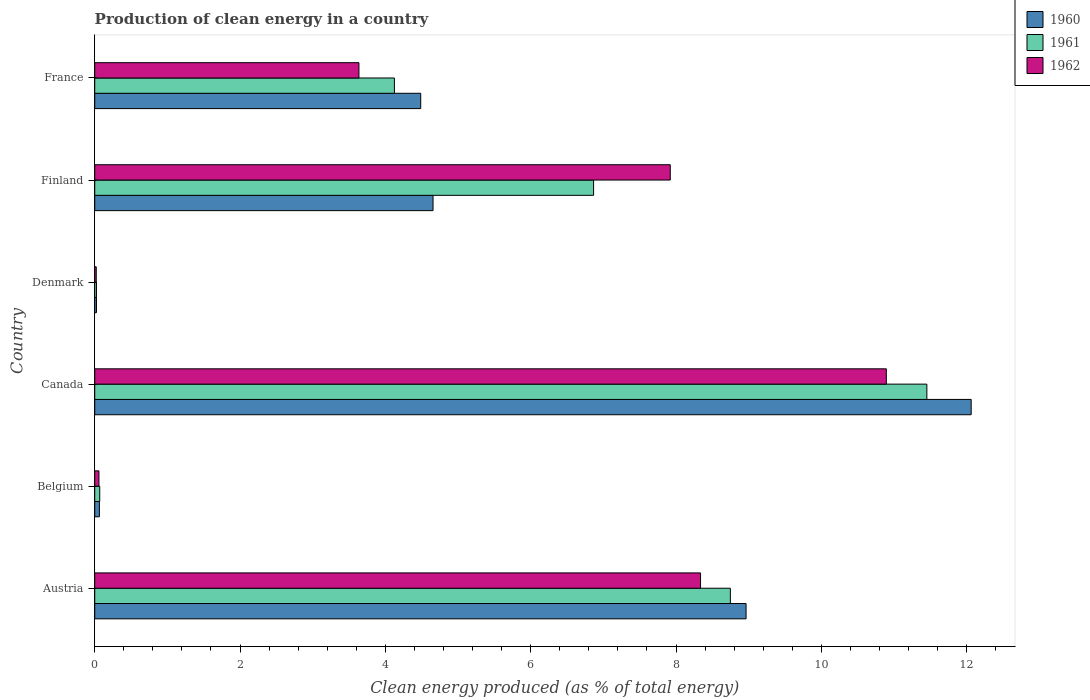How many different coloured bars are there?
Your answer should be very brief. 3. How many bars are there on the 4th tick from the bottom?
Make the answer very short. 3. What is the label of the 6th group of bars from the top?
Provide a succinct answer. Austria. What is the percentage of clean energy produced in 1960 in Belgium?
Ensure brevity in your answer.  0.06. Across all countries, what is the maximum percentage of clean energy produced in 1961?
Give a very brief answer. 11.45. Across all countries, what is the minimum percentage of clean energy produced in 1962?
Your response must be concise. 0.02. In which country was the percentage of clean energy produced in 1960 maximum?
Provide a short and direct response. Canada. What is the total percentage of clean energy produced in 1961 in the graph?
Provide a succinct answer. 31.28. What is the difference between the percentage of clean energy produced in 1961 in Denmark and that in Finland?
Offer a very short reply. -6.84. What is the difference between the percentage of clean energy produced in 1962 in Denmark and the percentage of clean energy produced in 1961 in Belgium?
Ensure brevity in your answer.  -0.05. What is the average percentage of clean energy produced in 1961 per country?
Keep it short and to the point. 5.21. What is the difference between the percentage of clean energy produced in 1961 and percentage of clean energy produced in 1962 in Finland?
Your answer should be compact. -1.06. In how many countries, is the percentage of clean energy produced in 1961 greater than 2.4 %?
Make the answer very short. 4. What is the ratio of the percentage of clean energy produced in 1960 in Canada to that in France?
Provide a short and direct response. 2.69. What is the difference between the highest and the second highest percentage of clean energy produced in 1961?
Keep it short and to the point. 2.7. What is the difference between the highest and the lowest percentage of clean energy produced in 1960?
Offer a very short reply. 12.04. Is the sum of the percentage of clean energy produced in 1962 in Belgium and Canada greater than the maximum percentage of clean energy produced in 1961 across all countries?
Your response must be concise. No. What does the 2nd bar from the top in Denmark represents?
Ensure brevity in your answer.  1961. Is it the case that in every country, the sum of the percentage of clean energy produced in 1960 and percentage of clean energy produced in 1962 is greater than the percentage of clean energy produced in 1961?
Your answer should be compact. Yes. How many bars are there?
Your answer should be compact. 18. How many countries are there in the graph?
Ensure brevity in your answer.  6. What is the difference between two consecutive major ticks on the X-axis?
Your answer should be compact. 2. Are the values on the major ticks of X-axis written in scientific E-notation?
Ensure brevity in your answer.  No. Where does the legend appear in the graph?
Your response must be concise. Top right. What is the title of the graph?
Your answer should be compact. Production of clean energy in a country. Does "2001" appear as one of the legend labels in the graph?
Offer a very short reply. No. What is the label or title of the X-axis?
Offer a very short reply. Clean energy produced (as % of total energy). What is the Clean energy produced (as % of total energy) in 1960 in Austria?
Provide a short and direct response. 8.96. What is the Clean energy produced (as % of total energy) in 1961 in Austria?
Make the answer very short. 8.75. What is the Clean energy produced (as % of total energy) of 1962 in Austria?
Your response must be concise. 8.34. What is the Clean energy produced (as % of total energy) of 1960 in Belgium?
Give a very brief answer. 0.06. What is the Clean energy produced (as % of total energy) of 1961 in Belgium?
Provide a succinct answer. 0.07. What is the Clean energy produced (as % of total energy) in 1962 in Belgium?
Ensure brevity in your answer.  0.06. What is the Clean energy produced (as % of total energy) in 1960 in Canada?
Offer a very short reply. 12.06. What is the Clean energy produced (as % of total energy) of 1961 in Canada?
Ensure brevity in your answer.  11.45. What is the Clean energy produced (as % of total energy) of 1962 in Canada?
Your response must be concise. 10.89. What is the Clean energy produced (as % of total energy) in 1960 in Denmark?
Provide a short and direct response. 0.02. What is the Clean energy produced (as % of total energy) of 1961 in Denmark?
Provide a short and direct response. 0.02. What is the Clean energy produced (as % of total energy) in 1962 in Denmark?
Your answer should be very brief. 0.02. What is the Clean energy produced (as % of total energy) of 1960 in Finland?
Make the answer very short. 4.66. What is the Clean energy produced (as % of total energy) of 1961 in Finland?
Ensure brevity in your answer.  6.87. What is the Clean energy produced (as % of total energy) of 1962 in Finland?
Offer a very short reply. 7.92. What is the Clean energy produced (as % of total energy) of 1960 in France?
Your answer should be very brief. 4.49. What is the Clean energy produced (as % of total energy) of 1961 in France?
Provide a succinct answer. 4.12. What is the Clean energy produced (as % of total energy) of 1962 in France?
Your answer should be compact. 3.64. Across all countries, what is the maximum Clean energy produced (as % of total energy) in 1960?
Your response must be concise. 12.06. Across all countries, what is the maximum Clean energy produced (as % of total energy) in 1961?
Offer a terse response. 11.45. Across all countries, what is the maximum Clean energy produced (as % of total energy) of 1962?
Your response must be concise. 10.89. Across all countries, what is the minimum Clean energy produced (as % of total energy) of 1960?
Your answer should be very brief. 0.02. Across all countries, what is the minimum Clean energy produced (as % of total energy) in 1961?
Provide a short and direct response. 0.02. Across all countries, what is the minimum Clean energy produced (as % of total energy) of 1962?
Provide a succinct answer. 0.02. What is the total Clean energy produced (as % of total energy) in 1960 in the graph?
Give a very brief answer. 30.26. What is the total Clean energy produced (as % of total energy) of 1961 in the graph?
Ensure brevity in your answer.  31.28. What is the total Clean energy produced (as % of total energy) in 1962 in the graph?
Your answer should be very brief. 30.87. What is the difference between the Clean energy produced (as % of total energy) in 1960 in Austria and that in Belgium?
Your answer should be very brief. 8.9. What is the difference between the Clean energy produced (as % of total energy) in 1961 in Austria and that in Belgium?
Your answer should be compact. 8.68. What is the difference between the Clean energy produced (as % of total energy) of 1962 in Austria and that in Belgium?
Offer a very short reply. 8.28. What is the difference between the Clean energy produced (as % of total energy) in 1960 in Austria and that in Canada?
Offer a terse response. -3.1. What is the difference between the Clean energy produced (as % of total energy) of 1961 in Austria and that in Canada?
Provide a succinct answer. -2.7. What is the difference between the Clean energy produced (as % of total energy) of 1962 in Austria and that in Canada?
Your response must be concise. -2.56. What is the difference between the Clean energy produced (as % of total energy) in 1960 in Austria and that in Denmark?
Make the answer very short. 8.94. What is the difference between the Clean energy produced (as % of total energy) in 1961 in Austria and that in Denmark?
Give a very brief answer. 8.72. What is the difference between the Clean energy produced (as % of total energy) in 1962 in Austria and that in Denmark?
Your answer should be compact. 8.32. What is the difference between the Clean energy produced (as % of total energy) of 1960 in Austria and that in Finland?
Offer a very short reply. 4.31. What is the difference between the Clean energy produced (as % of total energy) of 1961 in Austria and that in Finland?
Make the answer very short. 1.88. What is the difference between the Clean energy produced (as % of total energy) of 1962 in Austria and that in Finland?
Your answer should be very brief. 0.42. What is the difference between the Clean energy produced (as % of total energy) of 1960 in Austria and that in France?
Provide a succinct answer. 4.48. What is the difference between the Clean energy produced (as % of total energy) of 1961 in Austria and that in France?
Provide a succinct answer. 4.62. What is the difference between the Clean energy produced (as % of total energy) in 1962 in Austria and that in France?
Offer a terse response. 4.7. What is the difference between the Clean energy produced (as % of total energy) in 1960 in Belgium and that in Canada?
Offer a very short reply. -12. What is the difference between the Clean energy produced (as % of total energy) in 1961 in Belgium and that in Canada?
Provide a short and direct response. -11.38. What is the difference between the Clean energy produced (as % of total energy) of 1962 in Belgium and that in Canada?
Provide a short and direct response. -10.84. What is the difference between the Clean energy produced (as % of total energy) of 1960 in Belgium and that in Denmark?
Your answer should be very brief. 0.04. What is the difference between the Clean energy produced (as % of total energy) in 1961 in Belgium and that in Denmark?
Provide a succinct answer. 0.04. What is the difference between the Clean energy produced (as % of total energy) of 1962 in Belgium and that in Denmark?
Keep it short and to the point. 0.04. What is the difference between the Clean energy produced (as % of total energy) in 1960 in Belgium and that in Finland?
Provide a succinct answer. -4.59. What is the difference between the Clean energy produced (as % of total energy) in 1961 in Belgium and that in Finland?
Your response must be concise. -6.8. What is the difference between the Clean energy produced (as % of total energy) in 1962 in Belgium and that in Finland?
Make the answer very short. -7.86. What is the difference between the Clean energy produced (as % of total energy) of 1960 in Belgium and that in France?
Offer a very short reply. -4.42. What is the difference between the Clean energy produced (as % of total energy) of 1961 in Belgium and that in France?
Ensure brevity in your answer.  -4.06. What is the difference between the Clean energy produced (as % of total energy) of 1962 in Belgium and that in France?
Your response must be concise. -3.58. What is the difference between the Clean energy produced (as % of total energy) in 1960 in Canada and that in Denmark?
Your answer should be very brief. 12.04. What is the difference between the Clean energy produced (as % of total energy) in 1961 in Canada and that in Denmark?
Offer a terse response. 11.43. What is the difference between the Clean energy produced (as % of total energy) in 1962 in Canada and that in Denmark?
Ensure brevity in your answer.  10.87. What is the difference between the Clean energy produced (as % of total energy) of 1960 in Canada and that in Finland?
Your response must be concise. 7.41. What is the difference between the Clean energy produced (as % of total energy) in 1961 in Canada and that in Finland?
Ensure brevity in your answer.  4.59. What is the difference between the Clean energy produced (as % of total energy) of 1962 in Canada and that in Finland?
Keep it short and to the point. 2.97. What is the difference between the Clean energy produced (as % of total energy) of 1960 in Canada and that in France?
Give a very brief answer. 7.58. What is the difference between the Clean energy produced (as % of total energy) of 1961 in Canada and that in France?
Offer a very short reply. 7.33. What is the difference between the Clean energy produced (as % of total energy) in 1962 in Canada and that in France?
Make the answer very short. 7.26. What is the difference between the Clean energy produced (as % of total energy) of 1960 in Denmark and that in Finland?
Make the answer very short. -4.63. What is the difference between the Clean energy produced (as % of total energy) of 1961 in Denmark and that in Finland?
Offer a very short reply. -6.84. What is the difference between the Clean energy produced (as % of total energy) in 1962 in Denmark and that in Finland?
Your response must be concise. -7.9. What is the difference between the Clean energy produced (as % of total energy) of 1960 in Denmark and that in France?
Your answer should be very brief. -4.46. What is the difference between the Clean energy produced (as % of total energy) in 1961 in Denmark and that in France?
Provide a short and direct response. -4.1. What is the difference between the Clean energy produced (as % of total energy) in 1962 in Denmark and that in France?
Your answer should be compact. -3.62. What is the difference between the Clean energy produced (as % of total energy) of 1960 in Finland and that in France?
Offer a terse response. 0.17. What is the difference between the Clean energy produced (as % of total energy) of 1961 in Finland and that in France?
Keep it short and to the point. 2.74. What is the difference between the Clean energy produced (as % of total energy) in 1962 in Finland and that in France?
Make the answer very short. 4.28. What is the difference between the Clean energy produced (as % of total energy) of 1960 in Austria and the Clean energy produced (as % of total energy) of 1961 in Belgium?
Keep it short and to the point. 8.9. What is the difference between the Clean energy produced (as % of total energy) of 1960 in Austria and the Clean energy produced (as % of total energy) of 1962 in Belgium?
Provide a succinct answer. 8.91. What is the difference between the Clean energy produced (as % of total energy) of 1961 in Austria and the Clean energy produced (as % of total energy) of 1962 in Belgium?
Provide a short and direct response. 8.69. What is the difference between the Clean energy produced (as % of total energy) in 1960 in Austria and the Clean energy produced (as % of total energy) in 1961 in Canada?
Make the answer very short. -2.49. What is the difference between the Clean energy produced (as % of total energy) of 1960 in Austria and the Clean energy produced (as % of total energy) of 1962 in Canada?
Give a very brief answer. -1.93. What is the difference between the Clean energy produced (as % of total energy) in 1961 in Austria and the Clean energy produced (as % of total energy) in 1962 in Canada?
Give a very brief answer. -2.15. What is the difference between the Clean energy produced (as % of total energy) in 1960 in Austria and the Clean energy produced (as % of total energy) in 1961 in Denmark?
Provide a short and direct response. 8.94. What is the difference between the Clean energy produced (as % of total energy) of 1960 in Austria and the Clean energy produced (as % of total energy) of 1962 in Denmark?
Offer a terse response. 8.94. What is the difference between the Clean energy produced (as % of total energy) of 1961 in Austria and the Clean energy produced (as % of total energy) of 1962 in Denmark?
Offer a very short reply. 8.73. What is the difference between the Clean energy produced (as % of total energy) in 1960 in Austria and the Clean energy produced (as % of total energy) in 1961 in Finland?
Offer a terse response. 2.1. What is the difference between the Clean energy produced (as % of total energy) in 1960 in Austria and the Clean energy produced (as % of total energy) in 1962 in Finland?
Make the answer very short. 1.04. What is the difference between the Clean energy produced (as % of total energy) of 1961 in Austria and the Clean energy produced (as % of total energy) of 1962 in Finland?
Offer a terse response. 0.83. What is the difference between the Clean energy produced (as % of total energy) in 1960 in Austria and the Clean energy produced (as % of total energy) in 1961 in France?
Give a very brief answer. 4.84. What is the difference between the Clean energy produced (as % of total energy) of 1960 in Austria and the Clean energy produced (as % of total energy) of 1962 in France?
Give a very brief answer. 5.33. What is the difference between the Clean energy produced (as % of total energy) of 1961 in Austria and the Clean energy produced (as % of total energy) of 1962 in France?
Your response must be concise. 5.11. What is the difference between the Clean energy produced (as % of total energy) in 1960 in Belgium and the Clean energy produced (as % of total energy) in 1961 in Canada?
Offer a very short reply. -11.39. What is the difference between the Clean energy produced (as % of total energy) in 1960 in Belgium and the Clean energy produced (as % of total energy) in 1962 in Canada?
Offer a terse response. -10.83. What is the difference between the Clean energy produced (as % of total energy) of 1961 in Belgium and the Clean energy produced (as % of total energy) of 1962 in Canada?
Your response must be concise. -10.83. What is the difference between the Clean energy produced (as % of total energy) in 1960 in Belgium and the Clean energy produced (as % of total energy) in 1961 in Denmark?
Ensure brevity in your answer.  0.04. What is the difference between the Clean energy produced (as % of total energy) of 1960 in Belgium and the Clean energy produced (as % of total energy) of 1962 in Denmark?
Your response must be concise. 0.04. What is the difference between the Clean energy produced (as % of total energy) in 1961 in Belgium and the Clean energy produced (as % of total energy) in 1962 in Denmark?
Keep it short and to the point. 0.05. What is the difference between the Clean energy produced (as % of total energy) of 1960 in Belgium and the Clean energy produced (as % of total energy) of 1961 in Finland?
Your response must be concise. -6.8. What is the difference between the Clean energy produced (as % of total energy) in 1960 in Belgium and the Clean energy produced (as % of total energy) in 1962 in Finland?
Ensure brevity in your answer.  -7.86. What is the difference between the Clean energy produced (as % of total energy) of 1961 in Belgium and the Clean energy produced (as % of total energy) of 1962 in Finland?
Provide a short and direct response. -7.85. What is the difference between the Clean energy produced (as % of total energy) in 1960 in Belgium and the Clean energy produced (as % of total energy) in 1961 in France?
Make the answer very short. -4.06. What is the difference between the Clean energy produced (as % of total energy) in 1960 in Belgium and the Clean energy produced (as % of total energy) in 1962 in France?
Offer a terse response. -3.57. What is the difference between the Clean energy produced (as % of total energy) in 1961 in Belgium and the Clean energy produced (as % of total energy) in 1962 in France?
Your response must be concise. -3.57. What is the difference between the Clean energy produced (as % of total energy) of 1960 in Canada and the Clean energy produced (as % of total energy) of 1961 in Denmark?
Give a very brief answer. 12.04. What is the difference between the Clean energy produced (as % of total energy) of 1960 in Canada and the Clean energy produced (as % of total energy) of 1962 in Denmark?
Ensure brevity in your answer.  12.04. What is the difference between the Clean energy produced (as % of total energy) in 1961 in Canada and the Clean energy produced (as % of total energy) in 1962 in Denmark?
Keep it short and to the point. 11.43. What is the difference between the Clean energy produced (as % of total energy) in 1960 in Canada and the Clean energy produced (as % of total energy) in 1961 in Finland?
Your response must be concise. 5.2. What is the difference between the Clean energy produced (as % of total energy) in 1960 in Canada and the Clean energy produced (as % of total energy) in 1962 in Finland?
Keep it short and to the point. 4.14. What is the difference between the Clean energy produced (as % of total energy) of 1961 in Canada and the Clean energy produced (as % of total energy) of 1962 in Finland?
Offer a very short reply. 3.53. What is the difference between the Clean energy produced (as % of total energy) in 1960 in Canada and the Clean energy produced (as % of total energy) in 1961 in France?
Offer a terse response. 7.94. What is the difference between the Clean energy produced (as % of total energy) in 1960 in Canada and the Clean energy produced (as % of total energy) in 1962 in France?
Your answer should be very brief. 8.43. What is the difference between the Clean energy produced (as % of total energy) of 1961 in Canada and the Clean energy produced (as % of total energy) of 1962 in France?
Provide a short and direct response. 7.82. What is the difference between the Clean energy produced (as % of total energy) of 1960 in Denmark and the Clean energy produced (as % of total energy) of 1961 in Finland?
Give a very brief answer. -6.84. What is the difference between the Clean energy produced (as % of total energy) of 1960 in Denmark and the Clean energy produced (as % of total energy) of 1962 in Finland?
Give a very brief answer. -7.9. What is the difference between the Clean energy produced (as % of total energy) of 1961 in Denmark and the Clean energy produced (as % of total energy) of 1962 in Finland?
Offer a very short reply. -7.9. What is the difference between the Clean energy produced (as % of total energy) of 1960 in Denmark and the Clean energy produced (as % of total energy) of 1962 in France?
Your answer should be compact. -3.61. What is the difference between the Clean energy produced (as % of total energy) of 1961 in Denmark and the Clean energy produced (as % of total energy) of 1962 in France?
Your answer should be very brief. -3.61. What is the difference between the Clean energy produced (as % of total energy) in 1960 in Finland and the Clean energy produced (as % of total energy) in 1961 in France?
Make the answer very short. 0.53. What is the difference between the Clean energy produced (as % of total energy) of 1960 in Finland and the Clean energy produced (as % of total energy) of 1962 in France?
Ensure brevity in your answer.  1.02. What is the difference between the Clean energy produced (as % of total energy) of 1961 in Finland and the Clean energy produced (as % of total energy) of 1962 in France?
Give a very brief answer. 3.23. What is the average Clean energy produced (as % of total energy) of 1960 per country?
Provide a short and direct response. 5.04. What is the average Clean energy produced (as % of total energy) of 1961 per country?
Your answer should be compact. 5.21. What is the average Clean energy produced (as % of total energy) in 1962 per country?
Offer a terse response. 5.14. What is the difference between the Clean energy produced (as % of total energy) in 1960 and Clean energy produced (as % of total energy) in 1961 in Austria?
Your answer should be very brief. 0.22. What is the difference between the Clean energy produced (as % of total energy) of 1960 and Clean energy produced (as % of total energy) of 1962 in Austria?
Give a very brief answer. 0.63. What is the difference between the Clean energy produced (as % of total energy) in 1961 and Clean energy produced (as % of total energy) in 1962 in Austria?
Give a very brief answer. 0.41. What is the difference between the Clean energy produced (as % of total energy) of 1960 and Clean energy produced (as % of total energy) of 1961 in Belgium?
Give a very brief answer. -0. What is the difference between the Clean energy produced (as % of total energy) in 1960 and Clean energy produced (as % of total energy) in 1962 in Belgium?
Give a very brief answer. 0.01. What is the difference between the Clean energy produced (as % of total energy) of 1961 and Clean energy produced (as % of total energy) of 1962 in Belgium?
Make the answer very short. 0.01. What is the difference between the Clean energy produced (as % of total energy) in 1960 and Clean energy produced (as % of total energy) in 1961 in Canada?
Give a very brief answer. 0.61. What is the difference between the Clean energy produced (as % of total energy) in 1960 and Clean energy produced (as % of total energy) in 1962 in Canada?
Your answer should be very brief. 1.17. What is the difference between the Clean energy produced (as % of total energy) of 1961 and Clean energy produced (as % of total energy) of 1962 in Canada?
Offer a very short reply. 0.56. What is the difference between the Clean energy produced (as % of total energy) in 1960 and Clean energy produced (as % of total energy) in 1962 in Denmark?
Ensure brevity in your answer.  0. What is the difference between the Clean energy produced (as % of total energy) in 1961 and Clean energy produced (as % of total energy) in 1962 in Denmark?
Give a very brief answer. 0. What is the difference between the Clean energy produced (as % of total energy) of 1960 and Clean energy produced (as % of total energy) of 1961 in Finland?
Make the answer very short. -2.21. What is the difference between the Clean energy produced (as % of total energy) of 1960 and Clean energy produced (as % of total energy) of 1962 in Finland?
Your response must be concise. -3.26. What is the difference between the Clean energy produced (as % of total energy) in 1961 and Clean energy produced (as % of total energy) in 1962 in Finland?
Offer a very short reply. -1.06. What is the difference between the Clean energy produced (as % of total energy) of 1960 and Clean energy produced (as % of total energy) of 1961 in France?
Your answer should be very brief. 0.36. What is the difference between the Clean energy produced (as % of total energy) of 1960 and Clean energy produced (as % of total energy) of 1962 in France?
Offer a terse response. 0.85. What is the difference between the Clean energy produced (as % of total energy) of 1961 and Clean energy produced (as % of total energy) of 1962 in France?
Provide a short and direct response. 0.49. What is the ratio of the Clean energy produced (as % of total energy) in 1960 in Austria to that in Belgium?
Keep it short and to the point. 139.76. What is the ratio of the Clean energy produced (as % of total energy) in 1961 in Austria to that in Belgium?
Provide a short and direct response. 127.07. What is the ratio of the Clean energy produced (as % of total energy) in 1962 in Austria to that in Belgium?
Keep it short and to the point. 143.44. What is the ratio of the Clean energy produced (as % of total energy) in 1960 in Austria to that in Canada?
Provide a succinct answer. 0.74. What is the ratio of the Clean energy produced (as % of total energy) in 1961 in Austria to that in Canada?
Make the answer very short. 0.76. What is the ratio of the Clean energy produced (as % of total energy) of 1962 in Austria to that in Canada?
Give a very brief answer. 0.77. What is the ratio of the Clean energy produced (as % of total energy) in 1960 in Austria to that in Denmark?
Your answer should be very brief. 367.18. What is the ratio of the Clean energy produced (as % of total energy) in 1961 in Austria to that in Denmark?
Give a very brief answer. 365.06. What is the ratio of the Clean energy produced (as % of total energy) of 1962 in Austria to that in Denmark?
Give a very brief answer. 397.95. What is the ratio of the Clean energy produced (as % of total energy) of 1960 in Austria to that in Finland?
Your answer should be compact. 1.93. What is the ratio of the Clean energy produced (as % of total energy) in 1961 in Austria to that in Finland?
Offer a very short reply. 1.27. What is the ratio of the Clean energy produced (as % of total energy) of 1962 in Austria to that in Finland?
Provide a short and direct response. 1.05. What is the ratio of the Clean energy produced (as % of total energy) of 1960 in Austria to that in France?
Provide a short and direct response. 2. What is the ratio of the Clean energy produced (as % of total energy) of 1961 in Austria to that in France?
Your answer should be very brief. 2.12. What is the ratio of the Clean energy produced (as % of total energy) in 1962 in Austria to that in France?
Provide a short and direct response. 2.29. What is the ratio of the Clean energy produced (as % of total energy) of 1960 in Belgium to that in Canada?
Give a very brief answer. 0.01. What is the ratio of the Clean energy produced (as % of total energy) of 1961 in Belgium to that in Canada?
Give a very brief answer. 0.01. What is the ratio of the Clean energy produced (as % of total energy) of 1962 in Belgium to that in Canada?
Your answer should be very brief. 0.01. What is the ratio of the Clean energy produced (as % of total energy) of 1960 in Belgium to that in Denmark?
Keep it short and to the point. 2.63. What is the ratio of the Clean energy produced (as % of total energy) of 1961 in Belgium to that in Denmark?
Your answer should be very brief. 2.87. What is the ratio of the Clean energy produced (as % of total energy) of 1962 in Belgium to that in Denmark?
Ensure brevity in your answer.  2.77. What is the ratio of the Clean energy produced (as % of total energy) of 1960 in Belgium to that in Finland?
Offer a very short reply. 0.01. What is the ratio of the Clean energy produced (as % of total energy) of 1962 in Belgium to that in Finland?
Your answer should be compact. 0.01. What is the ratio of the Clean energy produced (as % of total energy) of 1960 in Belgium to that in France?
Make the answer very short. 0.01. What is the ratio of the Clean energy produced (as % of total energy) of 1961 in Belgium to that in France?
Give a very brief answer. 0.02. What is the ratio of the Clean energy produced (as % of total energy) of 1962 in Belgium to that in France?
Provide a short and direct response. 0.02. What is the ratio of the Clean energy produced (as % of total energy) of 1960 in Canada to that in Denmark?
Offer a very short reply. 494.07. What is the ratio of the Clean energy produced (as % of total energy) of 1961 in Canada to that in Denmark?
Your answer should be very brief. 477.92. What is the ratio of the Clean energy produced (as % of total energy) in 1962 in Canada to that in Denmark?
Your response must be concise. 520.01. What is the ratio of the Clean energy produced (as % of total energy) of 1960 in Canada to that in Finland?
Give a very brief answer. 2.59. What is the ratio of the Clean energy produced (as % of total energy) in 1961 in Canada to that in Finland?
Provide a succinct answer. 1.67. What is the ratio of the Clean energy produced (as % of total energy) in 1962 in Canada to that in Finland?
Offer a terse response. 1.38. What is the ratio of the Clean energy produced (as % of total energy) of 1960 in Canada to that in France?
Your answer should be very brief. 2.69. What is the ratio of the Clean energy produced (as % of total energy) in 1961 in Canada to that in France?
Your answer should be compact. 2.78. What is the ratio of the Clean energy produced (as % of total energy) of 1962 in Canada to that in France?
Provide a succinct answer. 3. What is the ratio of the Clean energy produced (as % of total energy) of 1960 in Denmark to that in Finland?
Your answer should be compact. 0.01. What is the ratio of the Clean energy produced (as % of total energy) of 1961 in Denmark to that in Finland?
Provide a short and direct response. 0. What is the ratio of the Clean energy produced (as % of total energy) of 1962 in Denmark to that in Finland?
Provide a succinct answer. 0. What is the ratio of the Clean energy produced (as % of total energy) of 1960 in Denmark to that in France?
Offer a terse response. 0.01. What is the ratio of the Clean energy produced (as % of total energy) in 1961 in Denmark to that in France?
Provide a short and direct response. 0.01. What is the ratio of the Clean energy produced (as % of total energy) in 1962 in Denmark to that in France?
Give a very brief answer. 0.01. What is the ratio of the Clean energy produced (as % of total energy) of 1960 in Finland to that in France?
Your answer should be compact. 1.04. What is the ratio of the Clean energy produced (as % of total energy) of 1961 in Finland to that in France?
Your answer should be very brief. 1.66. What is the ratio of the Clean energy produced (as % of total energy) in 1962 in Finland to that in France?
Your answer should be compact. 2.18. What is the difference between the highest and the second highest Clean energy produced (as % of total energy) of 1960?
Your answer should be compact. 3.1. What is the difference between the highest and the second highest Clean energy produced (as % of total energy) of 1961?
Your answer should be very brief. 2.7. What is the difference between the highest and the second highest Clean energy produced (as % of total energy) of 1962?
Give a very brief answer. 2.56. What is the difference between the highest and the lowest Clean energy produced (as % of total energy) in 1960?
Give a very brief answer. 12.04. What is the difference between the highest and the lowest Clean energy produced (as % of total energy) in 1961?
Your answer should be compact. 11.43. What is the difference between the highest and the lowest Clean energy produced (as % of total energy) in 1962?
Your answer should be compact. 10.87. 